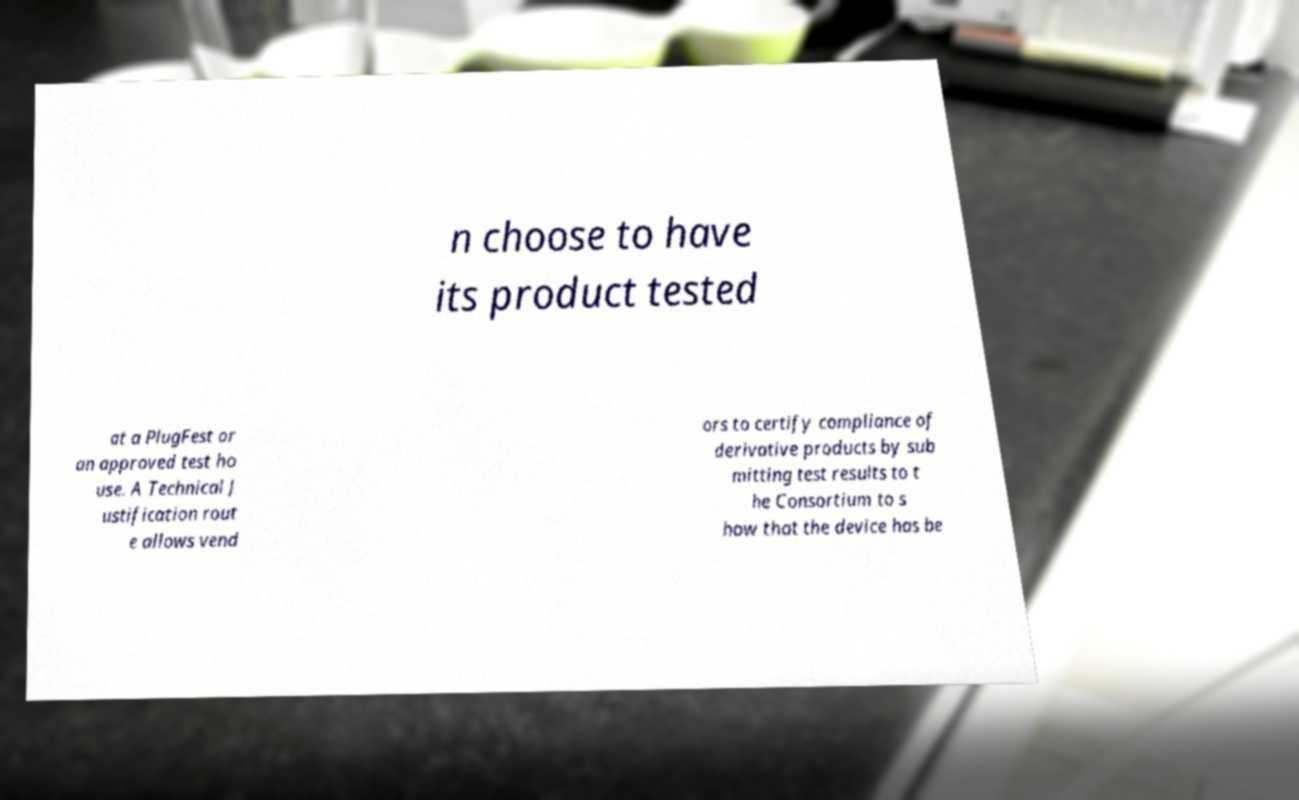Could you extract and type out the text from this image? n choose to have its product tested at a PlugFest or an approved test ho use. A Technical J ustification rout e allows vend ors to certify compliance of derivative products by sub mitting test results to t he Consortium to s how that the device has be 